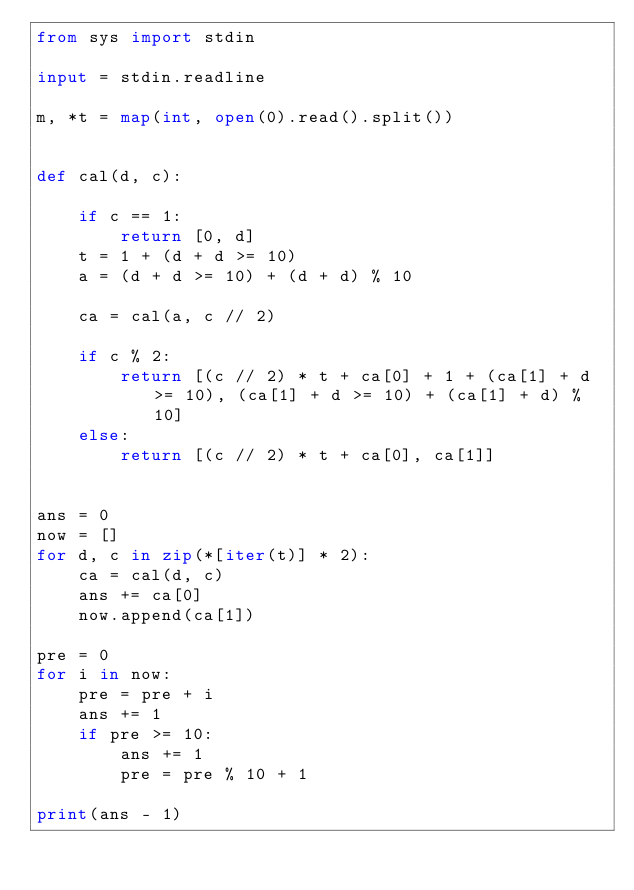Convert code to text. <code><loc_0><loc_0><loc_500><loc_500><_Python_>from sys import stdin

input = stdin.readline

m, *t = map(int, open(0).read().split())


def cal(d, c):

    if c == 1:
        return [0, d]
    t = 1 + (d + d >= 10)
    a = (d + d >= 10) + (d + d) % 10

    ca = cal(a, c // 2)

    if c % 2:
        return [(c // 2) * t + ca[0] + 1 + (ca[1] + d >= 10), (ca[1] + d >= 10) + (ca[1] + d) % 10]
    else:
        return [(c // 2) * t + ca[0], ca[1]]


ans = 0
now = []
for d, c in zip(*[iter(t)] * 2):
    ca = cal(d, c)
    ans += ca[0]
    now.append(ca[1])

pre = 0
for i in now:
    pre = pre + i
    ans += 1
    if pre >= 10:
        ans += 1
        pre = pre % 10 + 1

print(ans - 1)</code> 